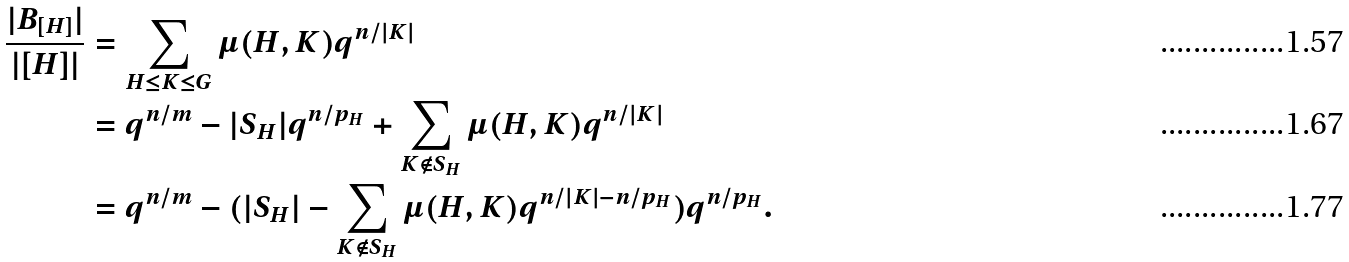<formula> <loc_0><loc_0><loc_500><loc_500>\frac { | B _ { [ H ] } | } { | [ H ] | } & = \sum _ { H \leq K \leq G } \mu ( H , K ) q ^ { n / | K | } \\ & = q ^ { n / m } - | S _ { H } | q ^ { n / p _ { H } } + \sum _ { K \notin S _ { H } } \mu ( H , K ) q ^ { n / | K | } \\ & = q ^ { n / m } - ( | S _ { H } | - \sum _ { K \notin S _ { H } } \mu ( H , K ) q ^ { n / | K | - n / p _ { H } } ) q ^ { n / p _ { H } } .</formula> 